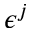<formula> <loc_0><loc_0><loc_500><loc_500>\epsilon ^ { j }</formula> 